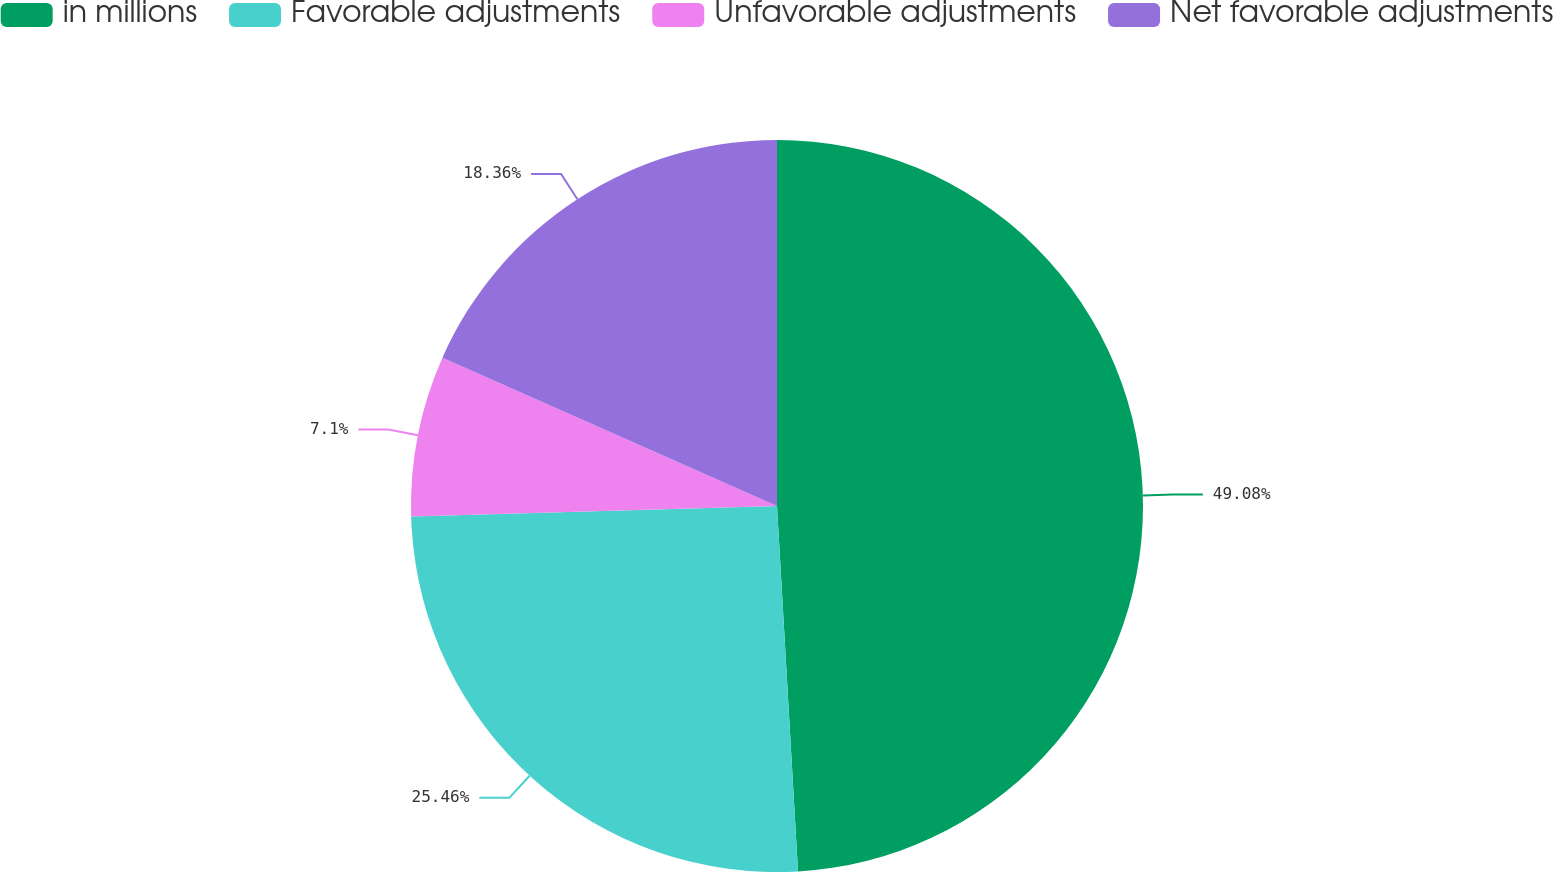Convert chart to OTSL. <chart><loc_0><loc_0><loc_500><loc_500><pie_chart><fcel>in millions<fcel>Favorable adjustments<fcel>Unfavorable adjustments<fcel>Net favorable adjustments<nl><fcel>49.09%<fcel>25.46%<fcel>7.1%<fcel>18.36%<nl></chart> 